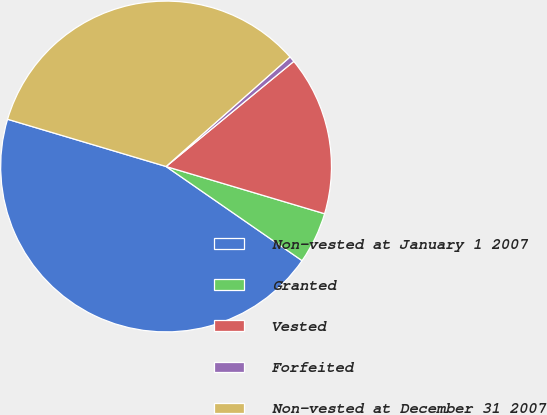Convert chart. <chart><loc_0><loc_0><loc_500><loc_500><pie_chart><fcel>Non-vested at January 1 2007<fcel>Granted<fcel>Vested<fcel>Forfeited<fcel>Non-vested at December 31 2007<nl><fcel>44.97%<fcel>5.03%<fcel>15.57%<fcel>0.56%<fcel>33.87%<nl></chart> 